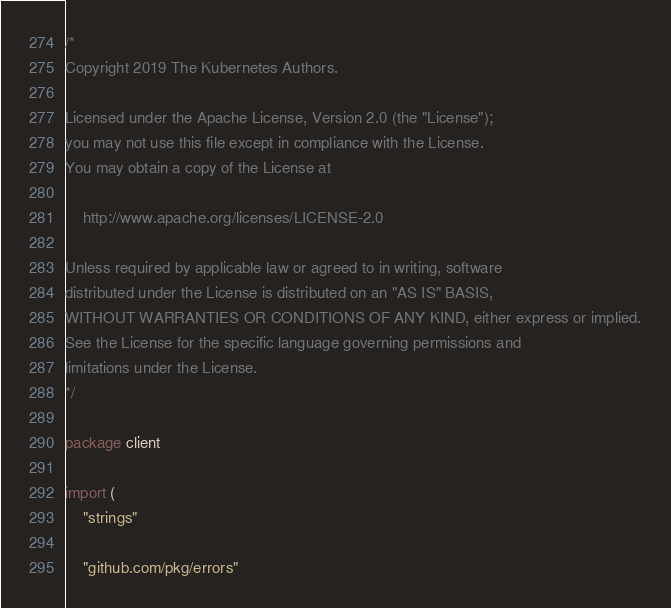<code> <loc_0><loc_0><loc_500><loc_500><_Go_>/*
Copyright 2019 The Kubernetes Authors.

Licensed under the Apache License, Version 2.0 (the "License");
you may not use this file except in compliance with the License.
You may obtain a copy of the License at

    http://www.apache.org/licenses/LICENSE-2.0

Unless required by applicable law or agreed to in writing, software
distributed under the License is distributed on an "AS IS" BASIS,
WITHOUT WARRANTIES OR CONDITIONS OF ANY KIND, either express or implied.
See the License for the specific language governing permissions and
limitations under the License.
*/

package client

import (
	"strings"

	"github.com/pkg/errors"</code> 